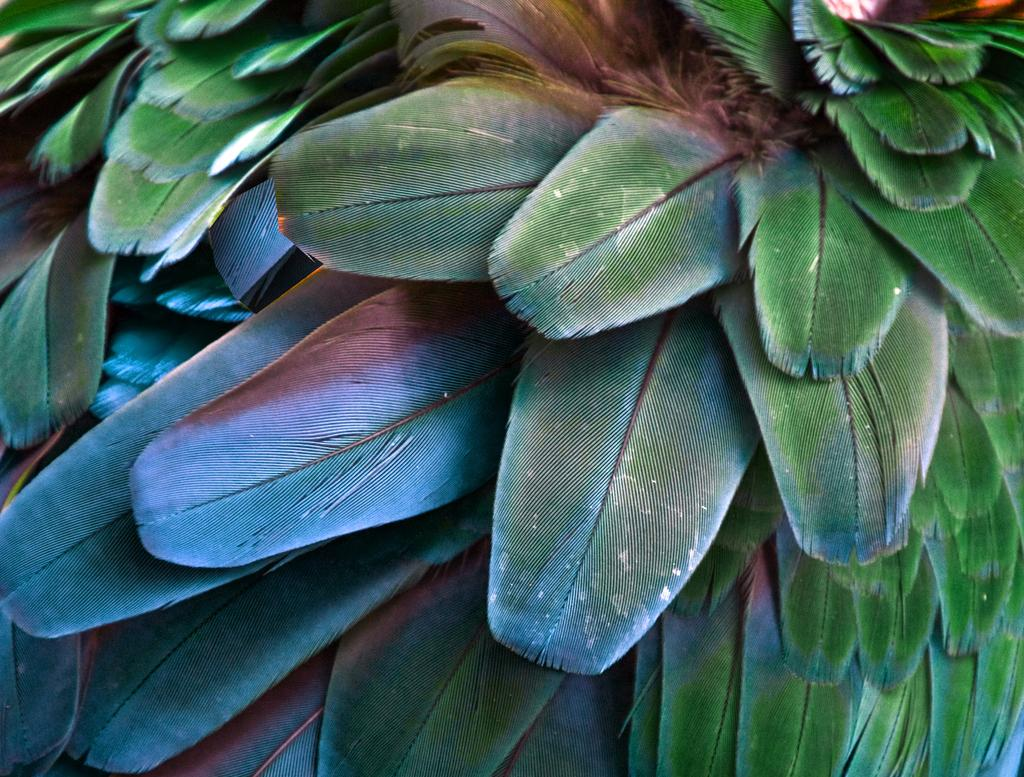What type of objects are present in the image? There are leaves of plants in the image. What can be said about the color of the leaves? The leaves are green in color. How many fingers can be seen on the leaves in the image? There are no fingers present on the leaves in the image, as leaves are plant parts and do not have fingers. 